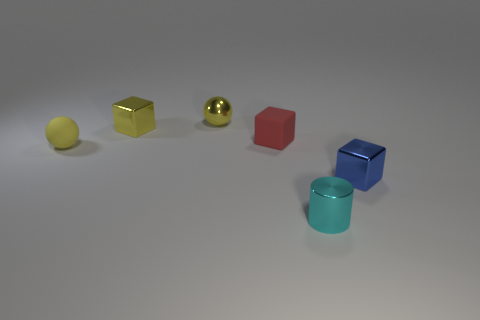Add 2 cyan things. How many objects exist? 8 Subtract all blue shiny cubes. How many cubes are left? 2 Subtract all cylinders. How many objects are left? 5 Subtract 0 purple spheres. How many objects are left? 6 Subtract all blue cubes. Subtract all blue cylinders. How many cubes are left? 2 Subtract all yellow metallic things. Subtract all rubber objects. How many objects are left? 2 Add 5 small rubber spheres. How many small rubber spheres are left? 6 Add 4 balls. How many balls exist? 6 